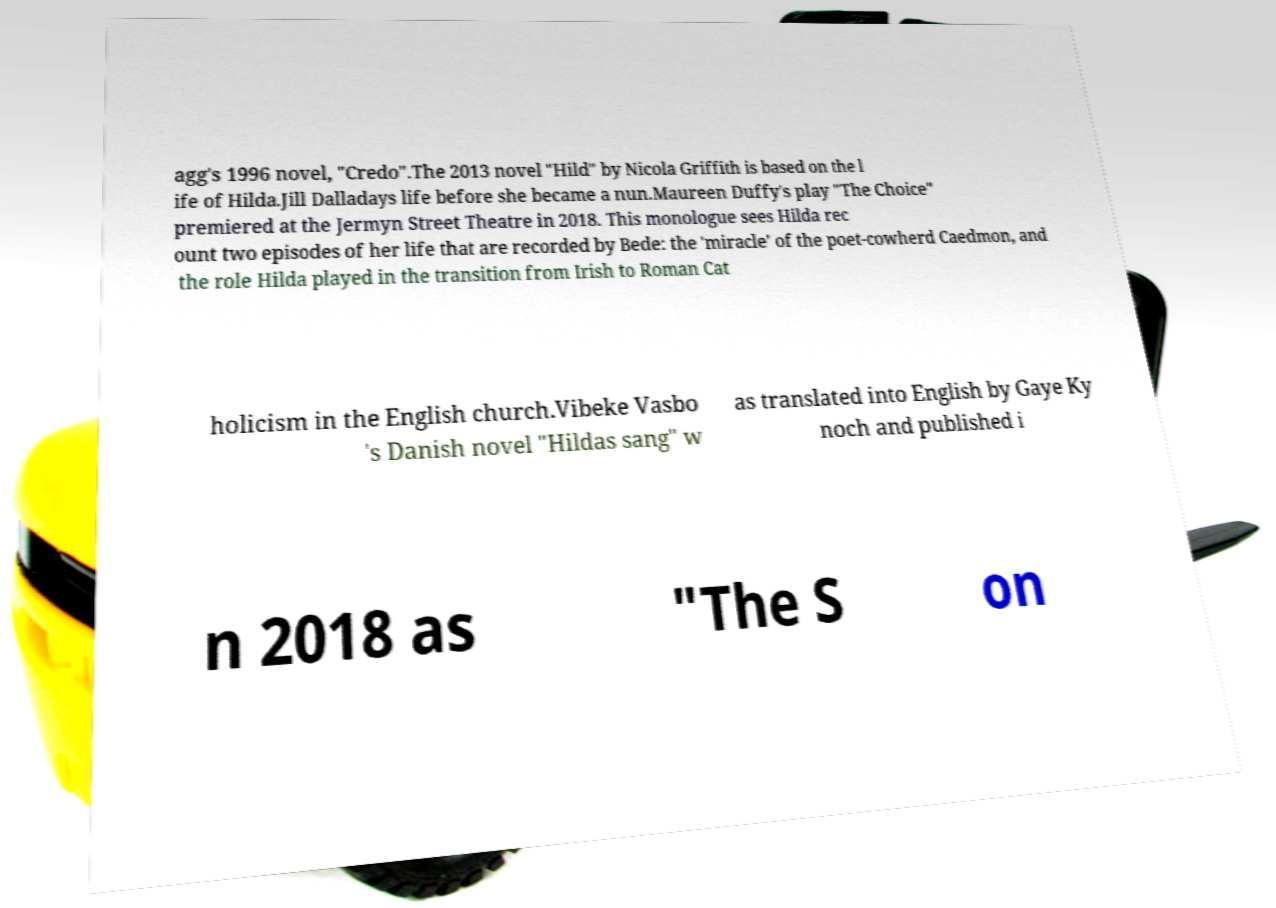Could you assist in decoding the text presented in this image and type it out clearly? agg's 1996 novel, "Credo".The 2013 novel "Hild" by Nicola Griffith is based on the l ife of Hilda.Jill Dalladays life before she became a nun.Maureen Duffy's play "The Choice" premiered at the Jermyn Street Theatre in 2018. This monologue sees Hilda rec ount two episodes of her life that are recorded by Bede: the 'miracle' of the poet-cowherd Caedmon, and the role Hilda played in the transition from Irish to Roman Cat holicism in the English church.Vibeke Vasbo 's Danish novel "Hildas sang" w as translated into English by Gaye Ky noch and published i n 2018 as "The S on 